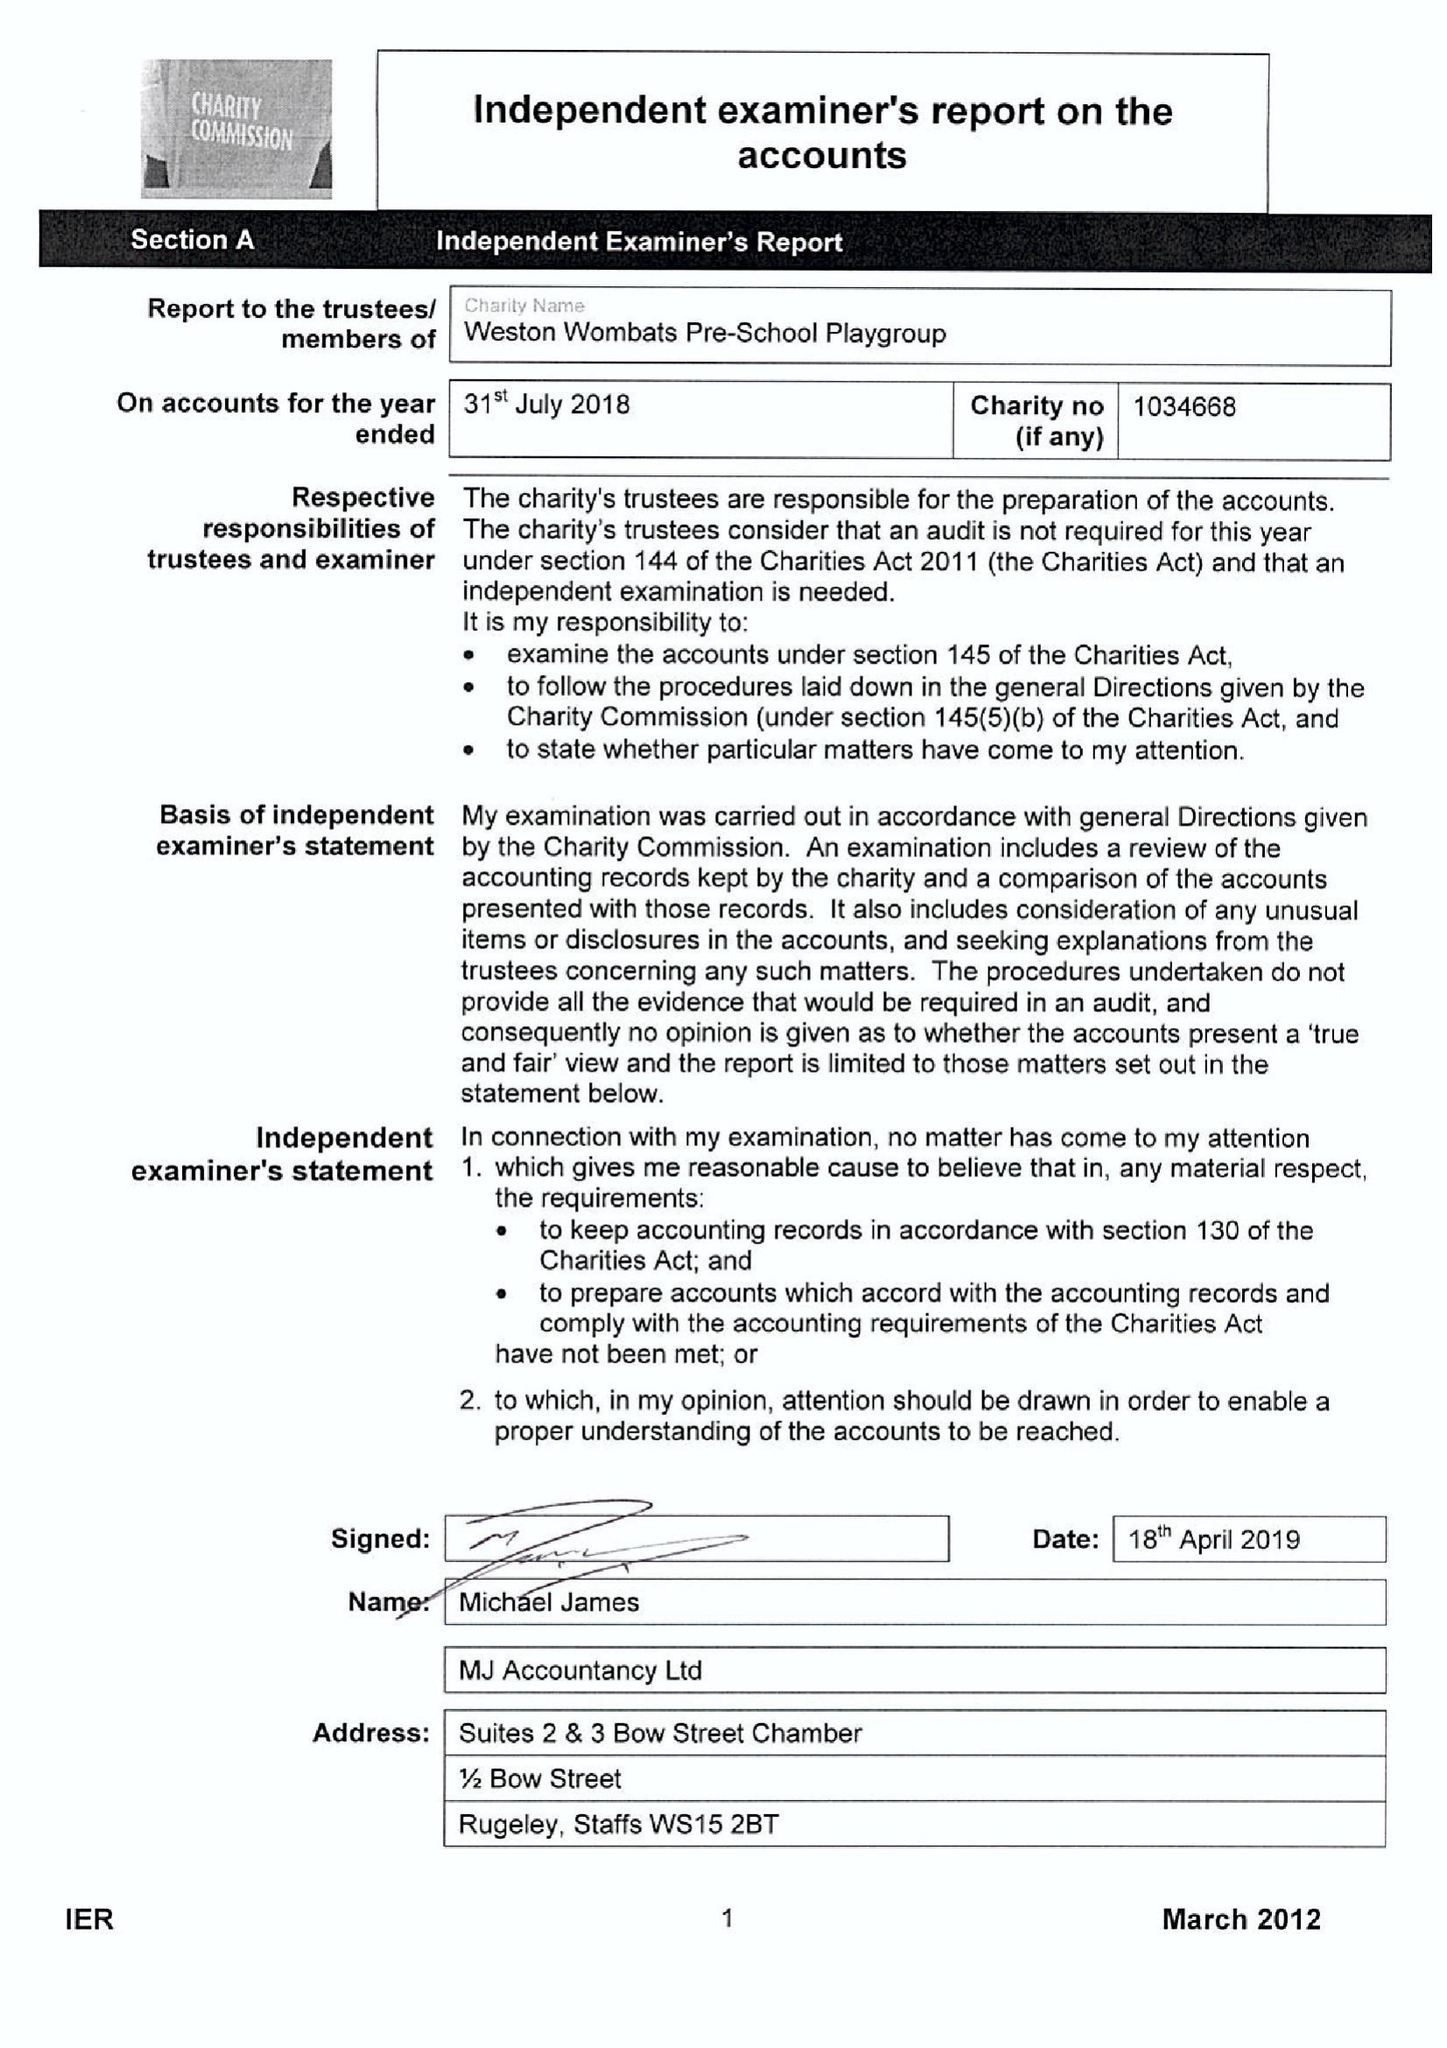What is the value for the income_annually_in_british_pounds?
Answer the question using a single word or phrase. 35357.22 